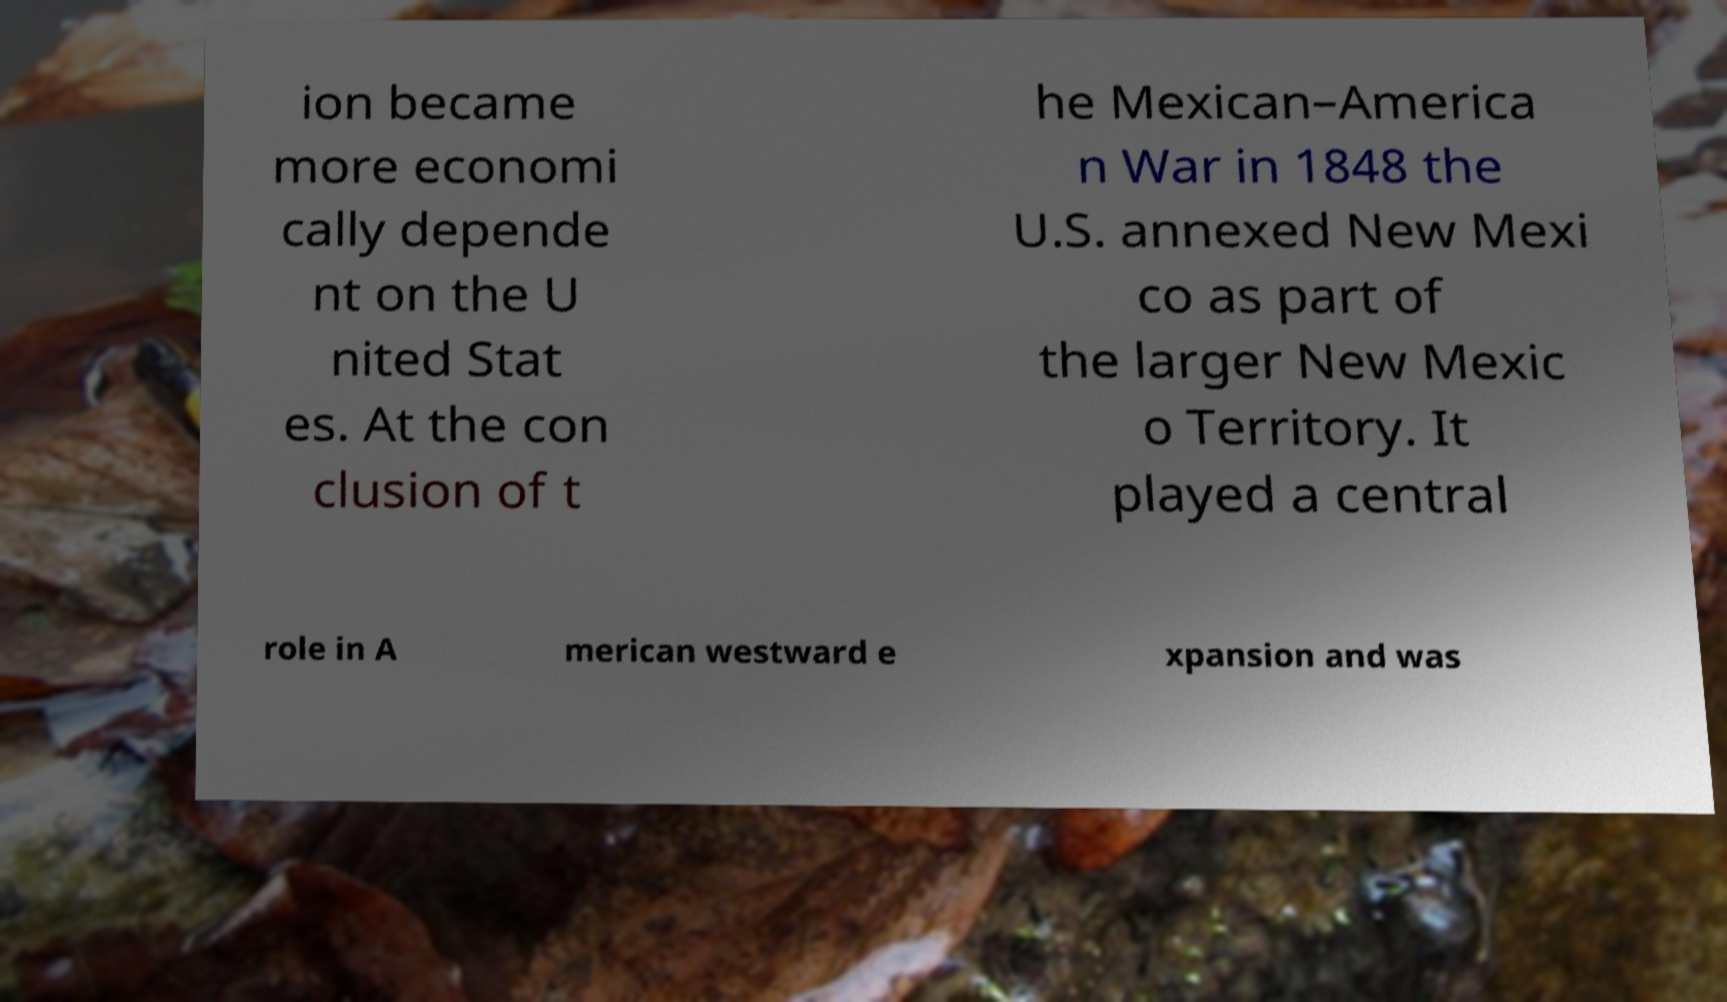For documentation purposes, I need the text within this image transcribed. Could you provide that? ion became more economi cally depende nt on the U nited Stat es. At the con clusion of t he Mexican–America n War in 1848 the U.S. annexed New Mexi co as part of the larger New Mexic o Territory. It played a central role in A merican westward e xpansion and was 